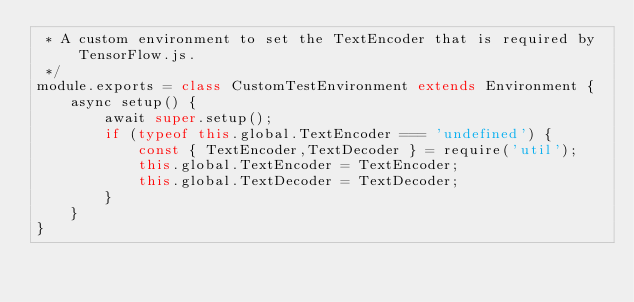<code> <loc_0><loc_0><loc_500><loc_500><_JavaScript_> * A custom environment to set the TextEncoder that is required by TensorFlow.js.
 */
module.exports = class CustomTestEnvironment extends Environment {
    async setup() {
        await super.setup();
        if (typeof this.global.TextEncoder === 'undefined') {
            const { TextEncoder,TextDecoder } = require('util');
            this.global.TextEncoder = TextEncoder;
            this.global.TextDecoder = TextDecoder;
        }
    }
}</code> 